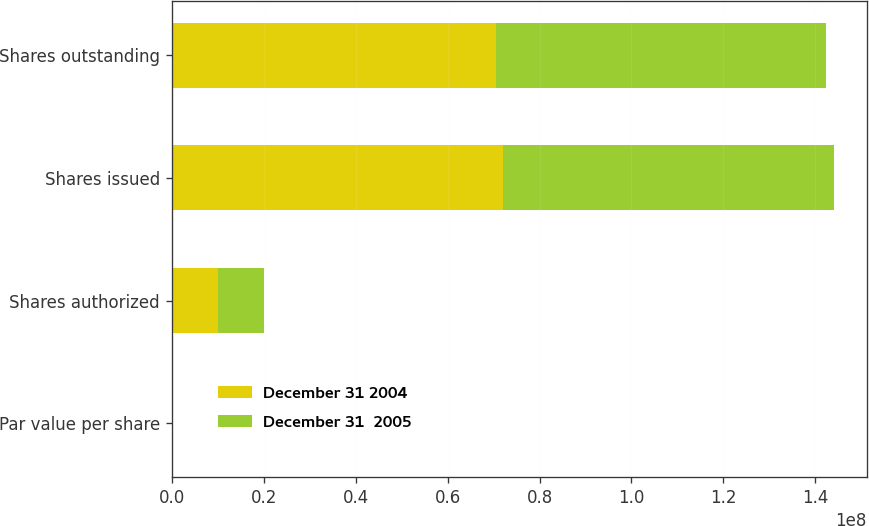<chart> <loc_0><loc_0><loc_500><loc_500><stacked_bar_chart><ecel><fcel>Par value per share<fcel>Shares authorized<fcel>Shares issued<fcel>Shares outstanding<nl><fcel>December 31 2004<fcel>0.01<fcel>1e+07<fcel>7.21519e+07<fcel>7.04511e+07<nl><fcel>December 31  2005<fcel>0.01<fcel>1e+07<fcel>7.18198e+07<fcel>7.18198e+07<nl></chart> 